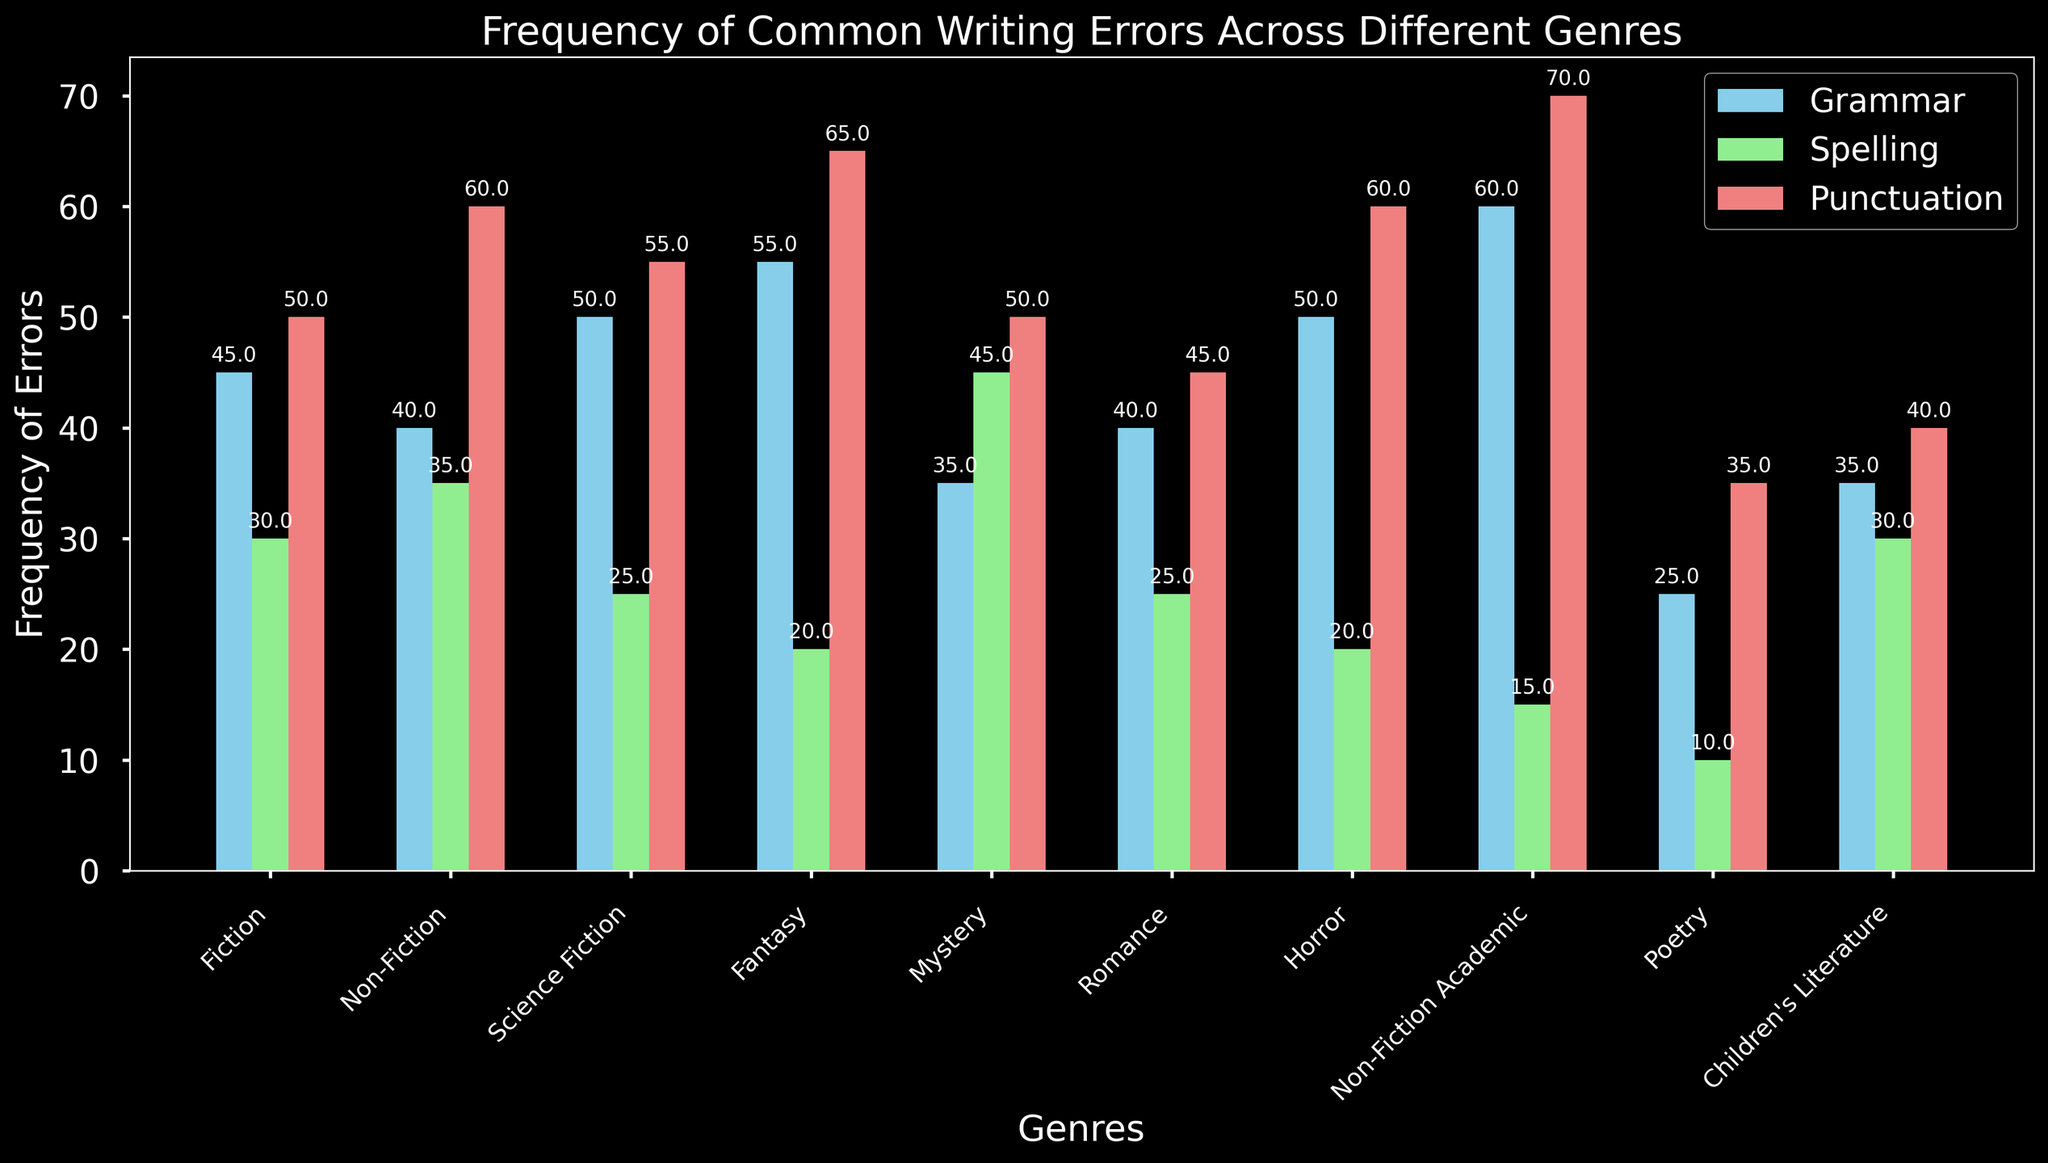Which genre has the highest frequency of grammar errors? To find the genre with the highest frequency of grammar errors, identify the bar representing grammar errors and compare their heights across all genres. The tallest bar corresponds to Non-Fiction Academic with 60 grammar errors.
Answer: Non-Fiction Academic Which genre has the lowest frequency of spelling errors? To find the genre with the lowest frequency of spelling errors, locate the bar representing spelling errors and compare their heights across all genres. The shortest bar corresponds to Poetry with 10 spelling errors.
Answer: Poetry How does the frequency of punctuation errors in Fantasy compare to Fiction? Compare the height of the bars representing punctuation errors for both Fantasy and Fiction. The Fantasy bar for punctuation errors is higher than the Fiction one, indicating Fantasy has more punctuation errors (65 compared to 50).
Answer: Fantasy has more punctuation errors than Fiction What is the total frequency of spelling errors across all genres? Sum the frequencies of spelling errors for each genre: 30 (Fiction) + 35 (Non-Fiction) + 25 (Science Fiction) + 20 (Fantasy) + 45 (Mystery) + 25 (Romance) + 20 (Horror) + 15 (Non-Fiction Academic) + 10 (Poetry) + 30 (Children's Literature) = 255.
Answer: 255 Which error type has the highest overall frequency in Non-Fiction? Compare the frequencies of different error types within Non-Fiction: Grammar (40), Spelling (35), and Punctuation (60). The highest frequency is for Punctuation.
Answer: Punctuation Is the frequency of grammar errors in Fiction higher or lower than in Science Fiction? Compare the heights of the bars representing grammar errors for Fiction (45) and Science Fiction (50). The bar for Science Fiction is higher.
Answer: Lower What's the average frequency of punctuation errors in Fiction, Mystery, and Horror? To find the average, sum the frequencies of punctuation errors in Fiction (50), Mystery (50), and Horror (60), then divide by the number of genres: (50 + 50 + 60) / 3 = 160 / 3 ≈ 53.33.
Answer: Approximately 53.33 How do the frequencies of spelling and grammar errors in Poetry compare? Compare the heights of the bars representing spelling and grammar errors in Poetry. Spelling errors (10) are lower than grammar errors (25) in Poetry.
Answer: Grammar errors are higher What is the difference between the highest and lowest frequencies of punctuation errors across all genres? Identify the highest and lowest frequencies of punctuation errors across all genres: The highest is 70 (Non-Fiction Academic), and the lowest is 35 (Poetry). The difference is 70 - 35 = 35.
Answer: 35 Which genre shows the most balanced frequency of errors across all three types? Find the genre where the bar heights for grammar, spelling, and punctuation errors are most similar. Fiction has the bars for Grammar (45), Spelling (30), and Punctuation (50), which are relatively close in height compared to other genres.
Answer: Fiction 